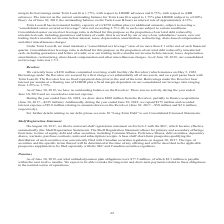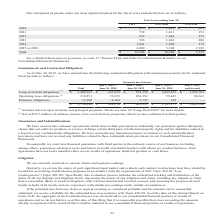According to Opentext Corporation's financial document, What does the table show? anticipated payments under our most significant plans for the fiscal years. The document states: "Our anticipated payments under our most significant plans for the fiscal years indicated below are as follows:..." Also, Where is a detailed discussion on pensions found? note 11 "Pension Plans and Other Post Retirement Benefits" to our Consolidated Financial Statements. The document states: "For a detailed discussion on pensions, see note 11 "Pension Plans and Other Post Retirement Benefits" to our Consolidated Financial Statements...." Also, What is the Total CDT for all years? According to the financial document, 10,248 (in thousands). The relevant text states: "1,050 272 2025 to 2028 6,009 5,308 2,389 Total $ 10,248 $ 10,468 $ 3,535..." Also, can you calculate: What is the CDT of Fiscal year 2020 expressed as a percentage of Total CDT? Based on the calculation: 675/10,248, the result is 6.59 (percentage). This is based on the information: "CDT GXS GER GXS PHP 2020 $ 675 $ 1,012 $ 161 2021 758 1,011 153 2022 832 1,044 352 2023 933 1,043 208 2024 1,041 1,050 272 2025 to 1,050 272 2025 to 2028 6,009 5,308 2,389 Total $ 10,248 $ 10,468 $ 3,..." The key data points involved are: 10,248, 675. Also, can you calculate: What is the total anticipated payments for all plans till fiscal year 2028? Based on the calculation: 10,248+10,468+3,535, the result is 24251 (in thousands). This is based on the information: "1,050 272 2025 to 2028 6,009 5,308 2,389 Total $ 10,248 $ 10,468 $ 3,535 2028 6,009 5,308 2,389 Total $ 10,248 $ 10,468 $ 3,535 2 2025 to 2028 6,009 5,308 2,389 Total $ 10,248 $ 10,468 $ 3,535..." The key data points involved are: 10,248, 10,468, 3,535. Also, can you calculate: What is the average annual payment for GXS PHP for fiscal year 2020 to 2024? To answer this question, I need to perform calculations using the financial data. The calculation is: (161+153+352+208+272)/5, which equals 229.2 (in thousands). This is based on the information: "CDT GXS GER GXS PHP 2020 $ 675 $ 1,012 $ 161 2021 758 1,011 153 2022 832 1,044 352 2023 933 1,043 208 2024 1,041 1,050 272 2025 to 2028 6,009 5, 832 1,044 352 2023 933 1,043 208 2024 1,041 1,050 272 2..." The key data points involved are: 153, 161, 208. 